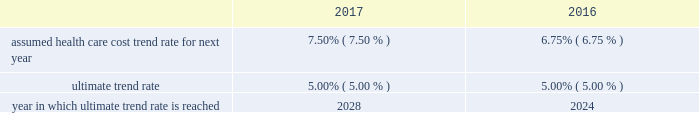Assumed health care cost trend rates for the u.s .
Retiree health care benefit plan as of december 31 are as follows: .
A one percentage point increase or decrease in health care cost trend rates over all future periods would have increased or decreased the accumulated postretirement benefit obligation for the u.s .
Retiree health care benefit plan as of december 31 , 2017 , by $ 1 million .
The service cost and interest cost components of 2017 plan expense would have increased or decreased by less than $ 1 million .
Deferred compensation arrangements we have a deferred compensation plan that allows u.s .
Employees whose base salary and management responsibility exceed a certain level to defer receipt of a portion of their cash compensation .
Payments under this plan are made based on the participant 2019s distribution election and plan balance .
Participants can earn a return on their deferred compensation based on notional investments in the same investment funds that are offered in our defined contribution plans .
As of december 31 , 2017 , our liability to participants of the deferred compensation plans was $ 255 million and is recorded in other long-term liabilities on our consolidated balance sheets .
This amount reflects the accumulated participant deferrals and earnings thereon as of that date .
As of december 31 , 2017 , we held $ 236 million in mutual funds related to these plans that are recorded in long-term investments on our consolidated balance sheets , and serve as an economic hedge against changes in fair values of our other deferred compensation liabilities .
We record changes in the fair value of the liability and the related investment in sg&a as discussed in note 8 .
11 .
Debt and lines of credit short-term borrowings we maintain a line of credit to support commercial paper borrowings , if any , and to provide additional liquidity through bank loans .
As of december 31 , 2017 , we had a variable-rate revolving credit facility from a consortium of investment-grade banks that allows us to borrow up to $ 2 billion until march 2022 .
The interest rate on borrowings under this credit facility , if drawn , is indexed to the applicable london interbank offered rate ( libor ) .
As of december 31 , 2017 , our credit facility was undrawn and we had no commercial paper outstanding .
Long-term debt we retired $ 250 million of maturing debt in march 2017 and another $ 375 million in june 2017 .
In may 2017 , we issued an aggregate principal amount of $ 600 million of fixed-rate , long-term debt .
The offering consisted of the reissuance of $ 300 million of 2.75% ( 2.75 % ) notes due in 2021 at a premium and the issuance of $ 300 million of 2.625% ( 2.625 % ) notes due in 2024 at a discount .
We incurred $ 3 million of issuance and other related costs .
The proceeds of the offerings were $ 605 million , net of the original issuance discount and premium , and were used for the repayment of maturing debt and general corporate purposes .
In november 2017 , we issued a principal amount of $ 500 million of fixed-rate , long-term debt due in 2027 .
We incurred $ 3 million of issuance and other related costs .
The proceeds of the offering were $ 494 million , net of the original issuance discount , and were used for general corporate purposes .
In may 2016 , we issued a principal amount of $ 500 million of fixed-rate , long-term debt due in 2022 .
We incurred $ 3 million of issuance and other related costs .
The proceeds of the offering were $ 499 million , net of the original issuance discount , and were used toward the repayment of a portion of $ 1.0 billion of maturing debt retired in may 2016 .
In may 2015 , we issued a principal amount of $ 500 million of fixed-rate , long-term debt due in 2020 .
We incurred $ 3 million of issuance and other related costs .
The proceeds of the offering were $ 498 million , net of the original issuance discount , and were used toward the repayment of a portion of the debt that matured in august 2015 .
We retired $ 250 million of maturing debt in april 2015 and another $ 750 million in august 2015 .
Texas instruments 2022 2017 form 10-k 51 .
What was the total long-term debt retired in 2017? 
Computations: (250 + 375)
Answer: 625.0. 